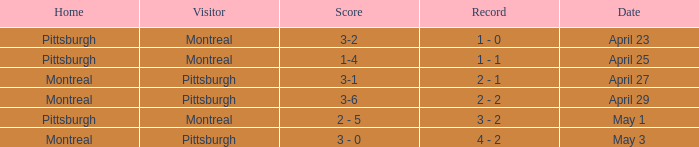Who visited on April 29? Pittsburgh. 